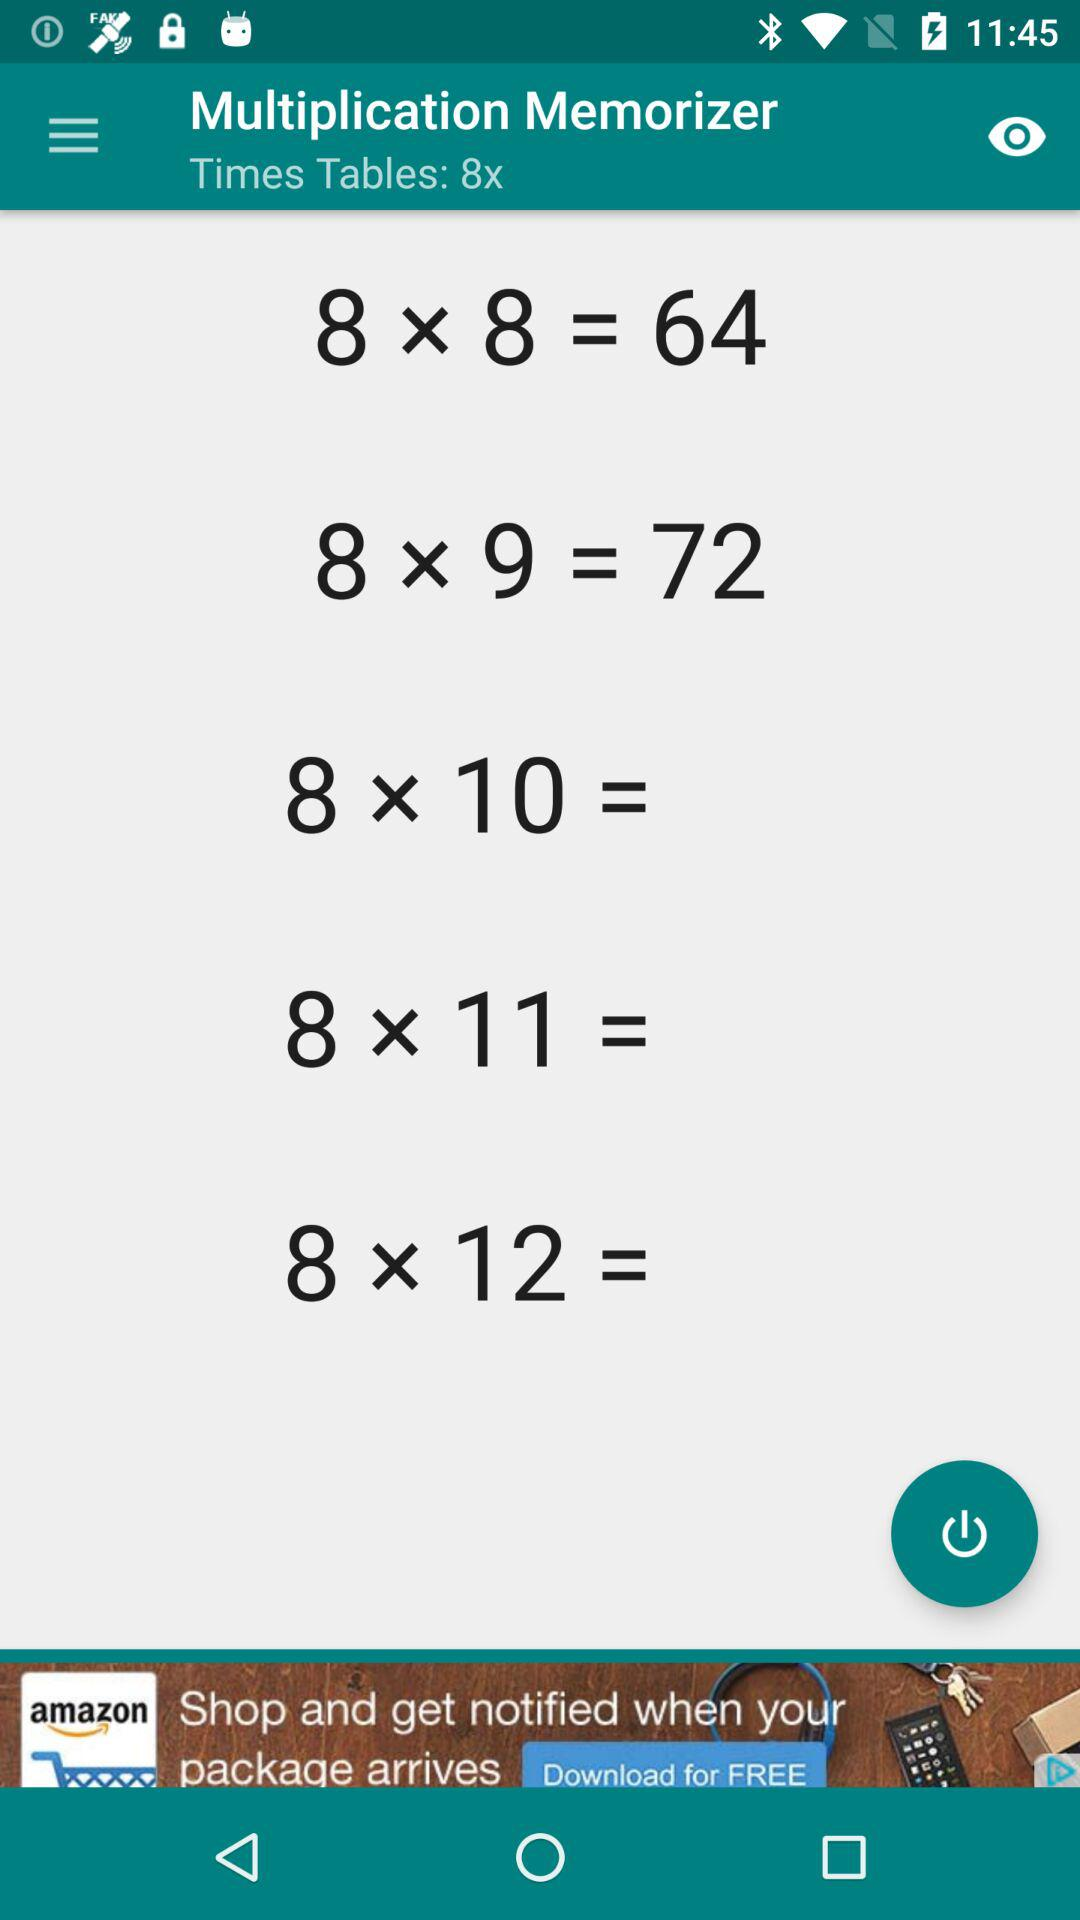What is the application name? The application name is "Multiplication Memorizer". 